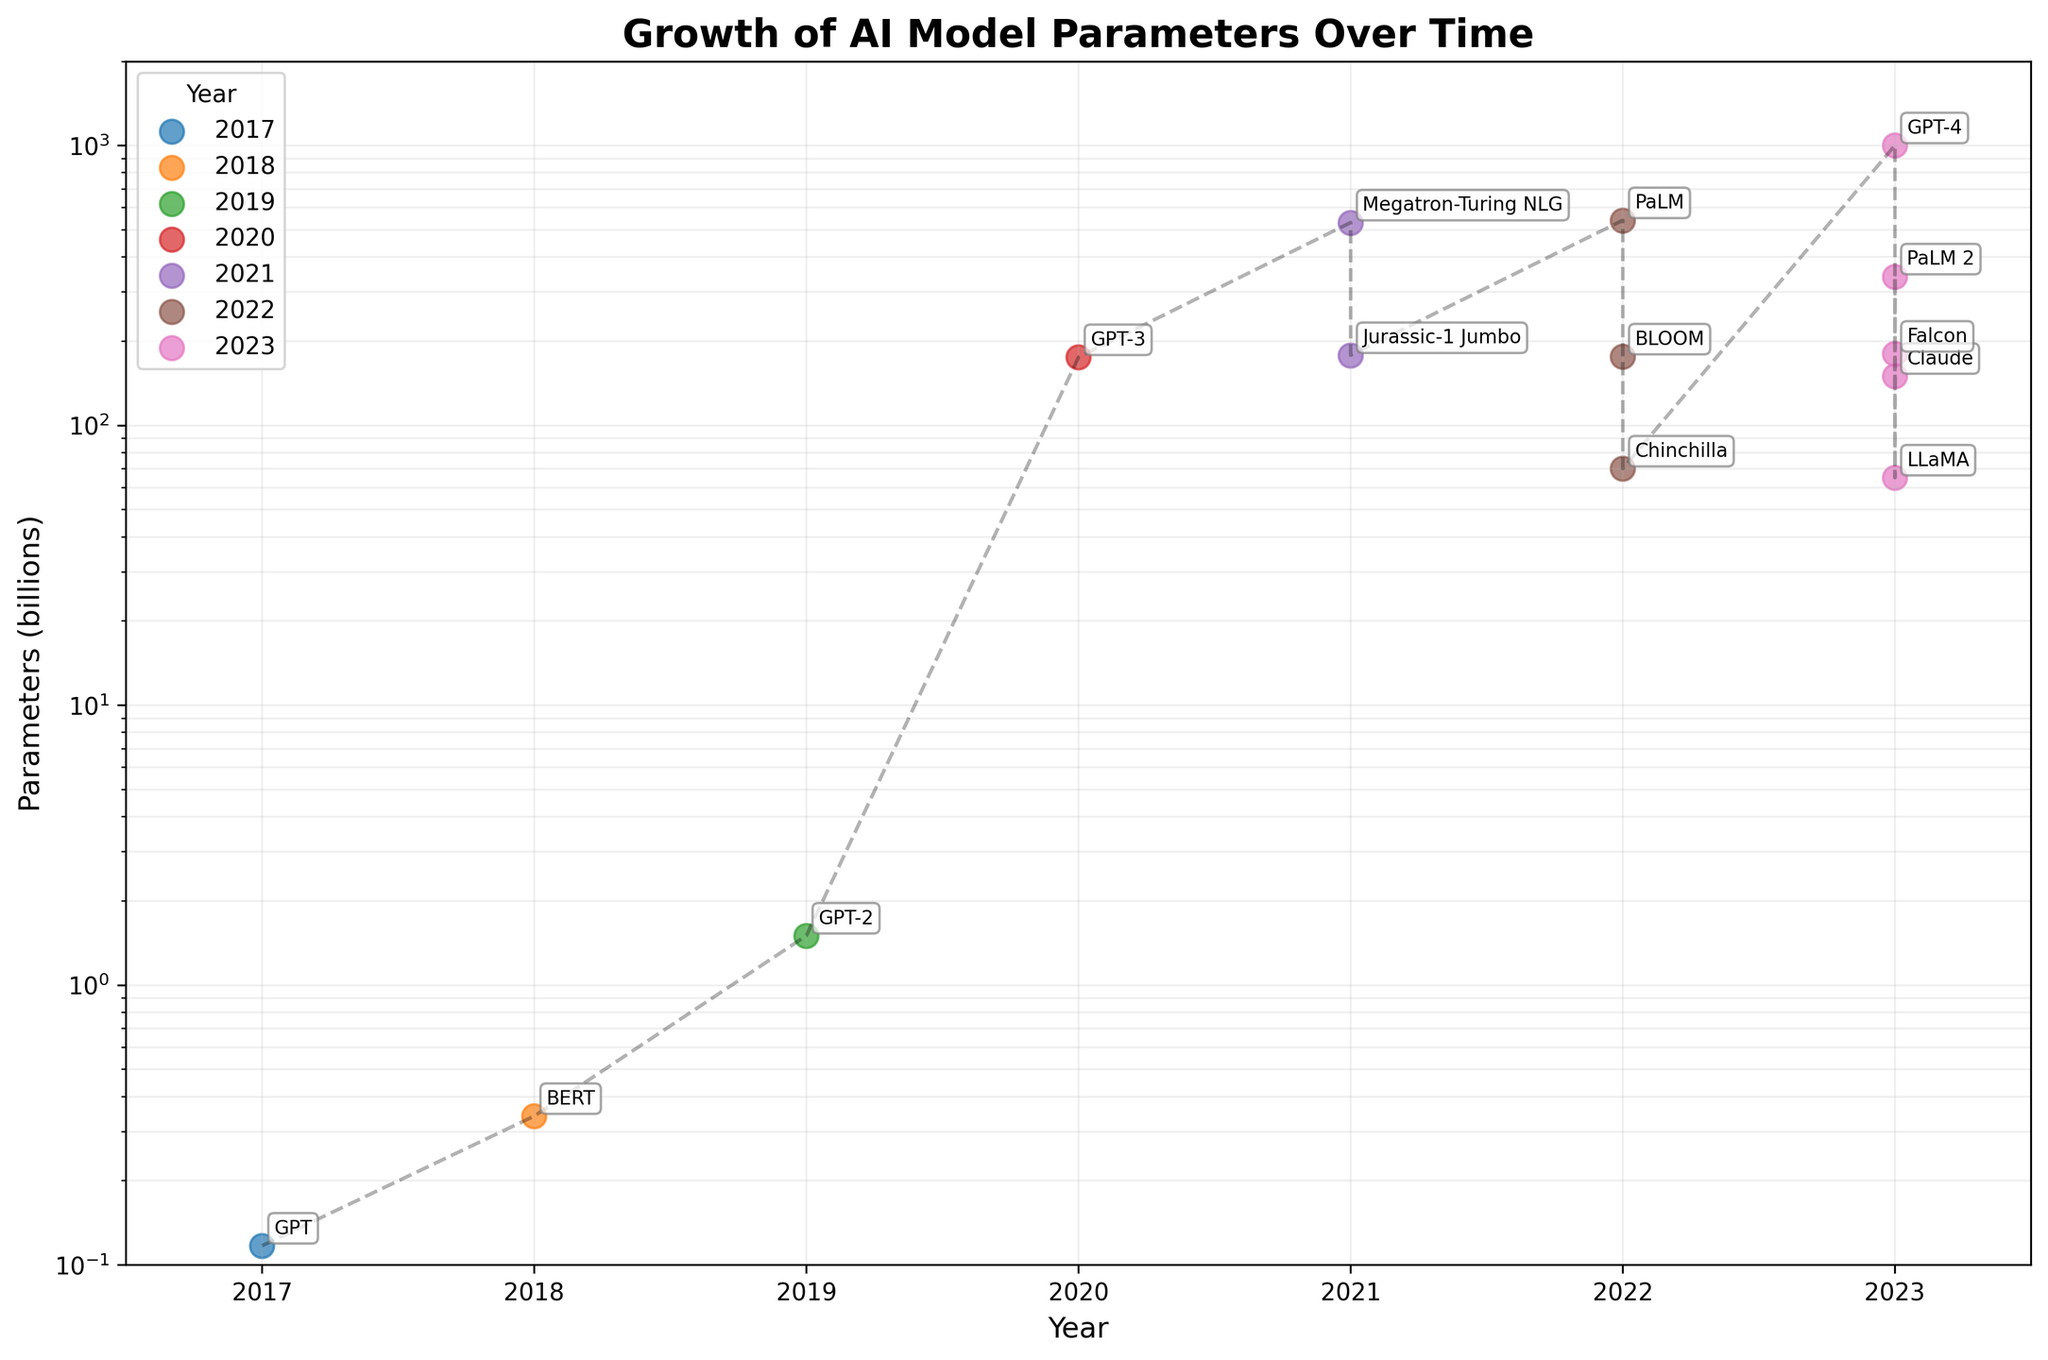Which model had the highest number of parameters in 2023? Look at the year 2023 and identify the model with the highest number of parameters. The model with the highest parameters is GPT-4 with 1000 billion parameters.
Answer: GPT-4 Between which years did the most significant jump in model parameters occur? The most significant jump is identified by looking for the largest vertical leap in parameter values. The jump between 2019 and 2020 (from GPT-2 to GPT-3) was from 1.5 to 175 billion parameters.
Answer: 2019-2020 How many models in 2023 have more than 200 billion parameters? Identify the models from 2023 and count how many have parameters greater than 200 billion. GPT-4, PaLM 2, and Claude exceed 200 billion parameters.
Answer: 3 What is the average number of parameters for models released in 2022? Average is calculated by summing the parameters of models in 2022 (PaLM: 540, BLOOM: 176, Chinchilla: 70), and dividing by the number of models. (540 + 176 + 70) / 3 = 262
Answer: 262 Which year had the highest diversity in model parameters? Look at the range of parameter values for each year. 2023 has a high diversity with models ranging from 65 to 1000 billion parameters.
Answer: 2023 Which model is the smallest among those released in 2022? Identify and compare the models from 2022 by their parameters. Chinchilla has the smallest number of parameters at 70 billion.
Answer: Chinchilla What is the difference in parameters between the largest and smallest model in 2021? Identify the models for 2021: Megatron-Turing NLG (530) and Jurassic-1 Jumbo (178). Calculate the difference: 530 - 178 = 352.
Answer: 352 How many models released between 2017 and 2019 have less than 1 billion parameters? Check the models from 2017, 2018, and 2019: GPT (0.117) and BERT (0.34) have less than 1 billion parameters.
Answer: 2 Compare the growth in AI model parameters between 2019 and 2020 to the growth between 2022 and 2023 Calculate the change from 2019 to 2020 (175 - 1.5 = 173.5) and from 2022 to 2023 (1000 - 540 = 460), showing larger growth from 2022 to 2023.
Answer: Greater in 2022-2023 